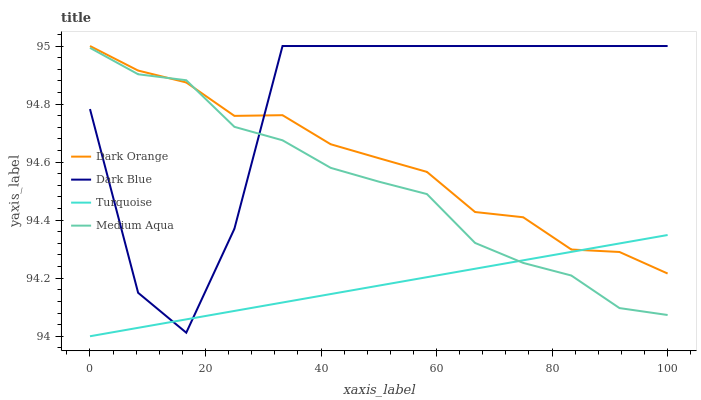Does Turquoise have the minimum area under the curve?
Answer yes or no. Yes. Does Dark Blue have the maximum area under the curve?
Answer yes or no. Yes. Does Medium Aqua have the minimum area under the curve?
Answer yes or no. No. Does Medium Aqua have the maximum area under the curve?
Answer yes or no. No. Is Turquoise the smoothest?
Answer yes or no. Yes. Is Dark Blue the roughest?
Answer yes or no. Yes. Is Medium Aqua the smoothest?
Answer yes or no. No. Is Medium Aqua the roughest?
Answer yes or no. No. Does Turquoise have the lowest value?
Answer yes or no. Yes. Does Medium Aqua have the lowest value?
Answer yes or no. No. Does Dark Blue have the highest value?
Answer yes or no. Yes. Does Medium Aqua have the highest value?
Answer yes or no. No. Does Turquoise intersect Dark Blue?
Answer yes or no. Yes. Is Turquoise less than Dark Blue?
Answer yes or no. No. Is Turquoise greater than Dark Blue?
Answer yes or no. No. 